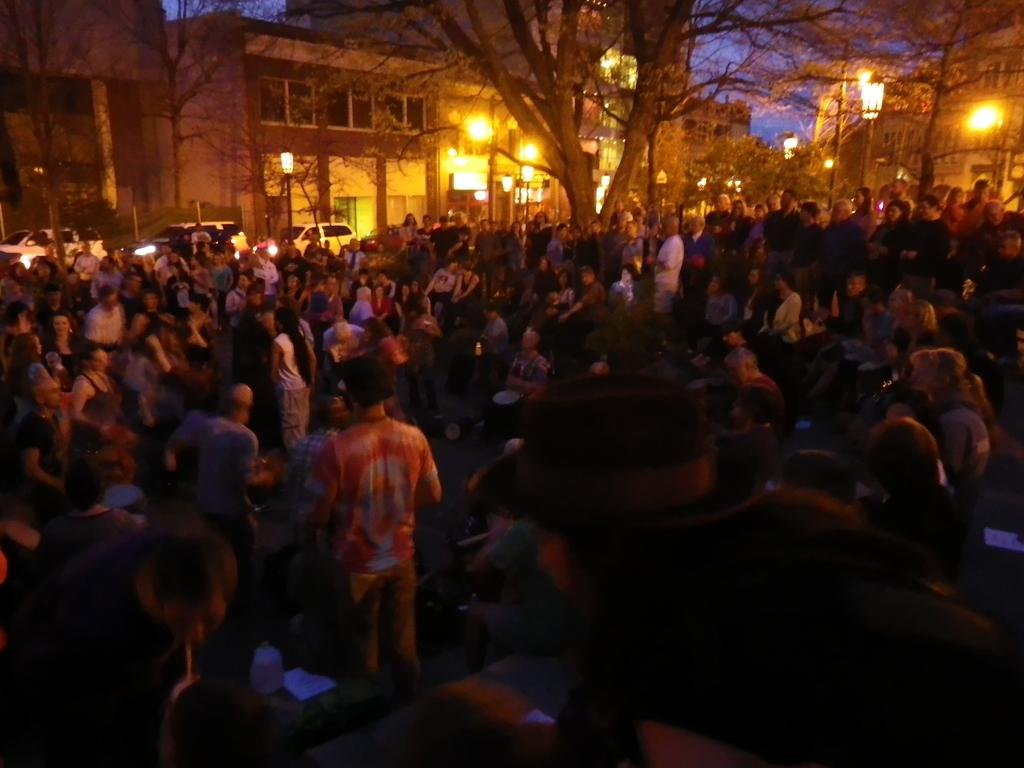How many people are in the image? There is a group of people standing in the image. What can be seen in the image besides the people? There are lights, poles, vehicles, trees, buildings, and the sky visible in the image. What type of structures are present in the image? There are poles and buildings in the image. What is visible in the background of the image? The sky is visible in the background of the image. What type of apparatus is being used to adjust the cork in the image? There is no apparatus, adjustment, or cork present in the image. 